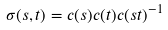<formula> <loc_0><loc_0><loc_500><loc_500>\sigma ( s , t ) = c ( s ) c ( t ) c ( s t ) ^ { - 1 }</formula> 